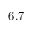<formula> <loc_0><loc_0><loc_500><loc_500>6 . 7</formula> 